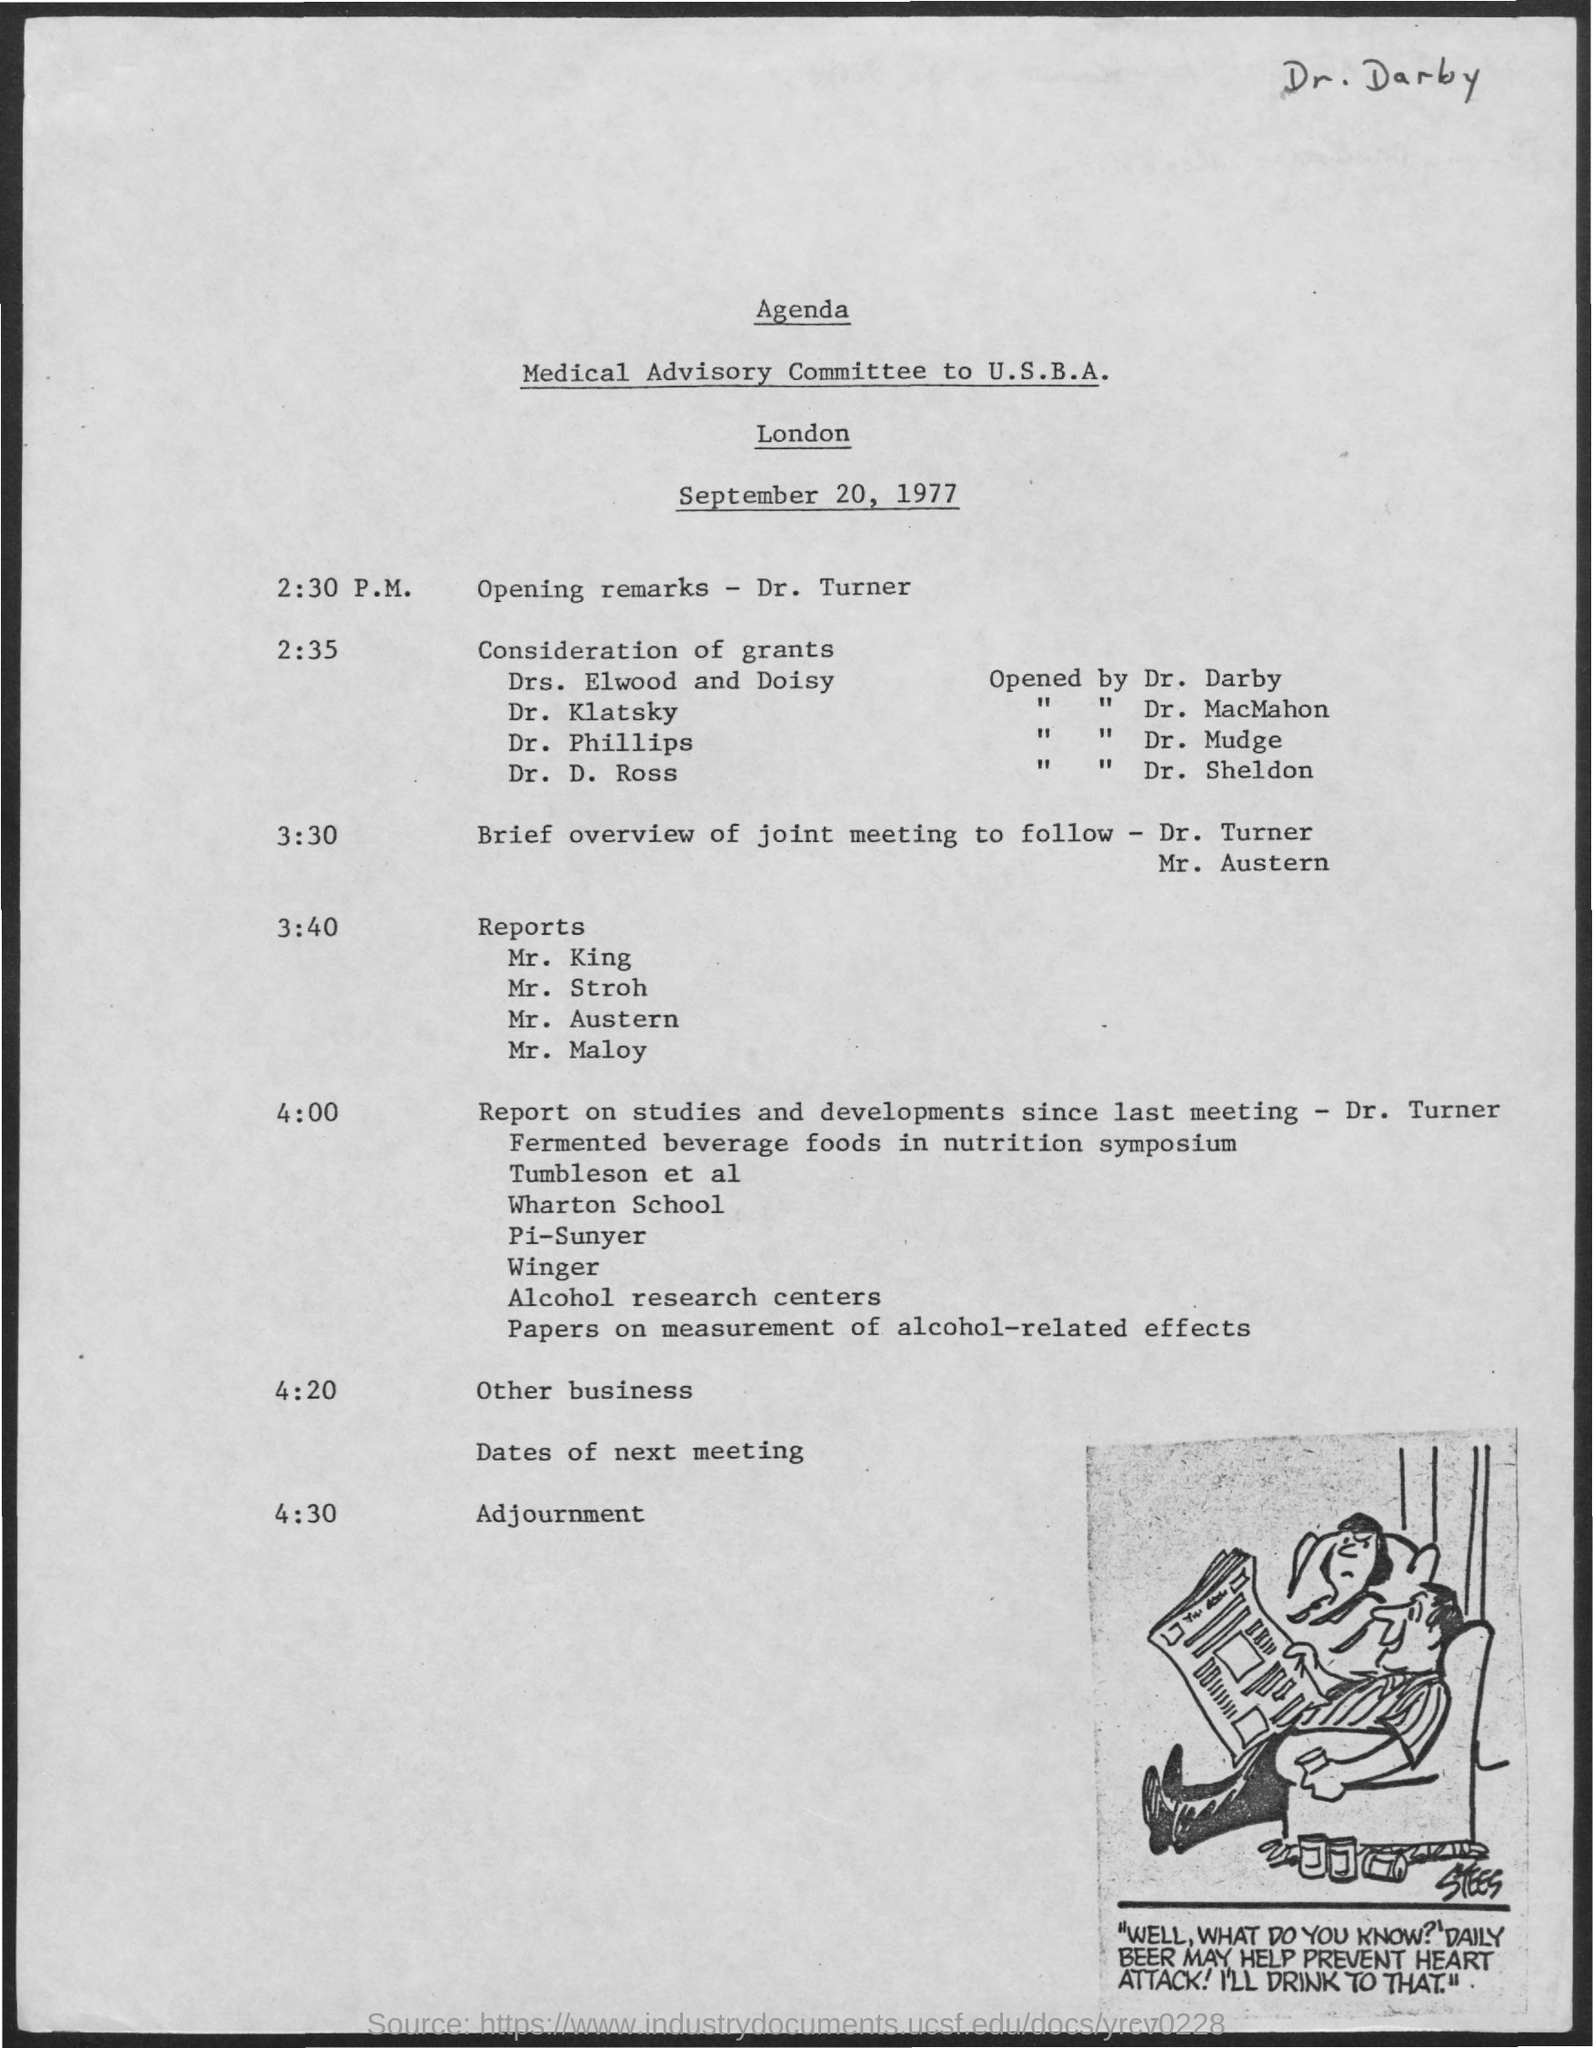What is the date mentioned in the given page ?
Make the answer very short. September 20, 1977. What is the schedule at the time of 2:30 p.m. ?
Make the answer very short. Opening remarks. What is  the schedule at the time of 2:35 ?
Provide a succinct answer. Consideration of grants. What is the schedule at the time of 3:40 ?
Provide a succinct answer. Reports. What is the schedule at the time of 4:30 ?
Your answer should be compact. Adjournment. 